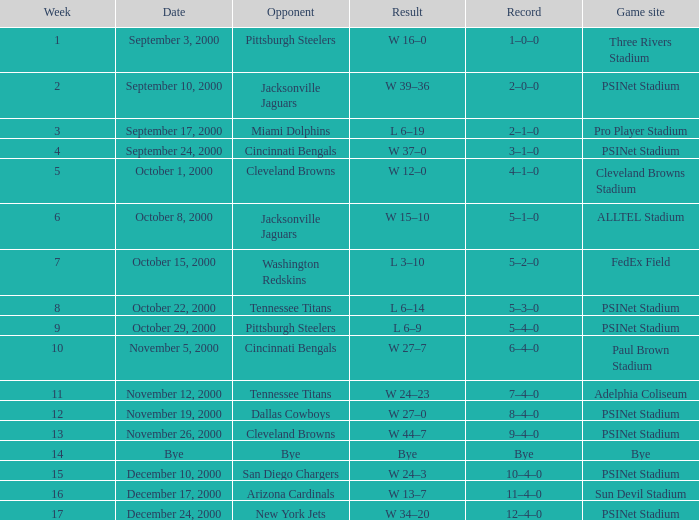What's the record after week 16? 12–4–0. 